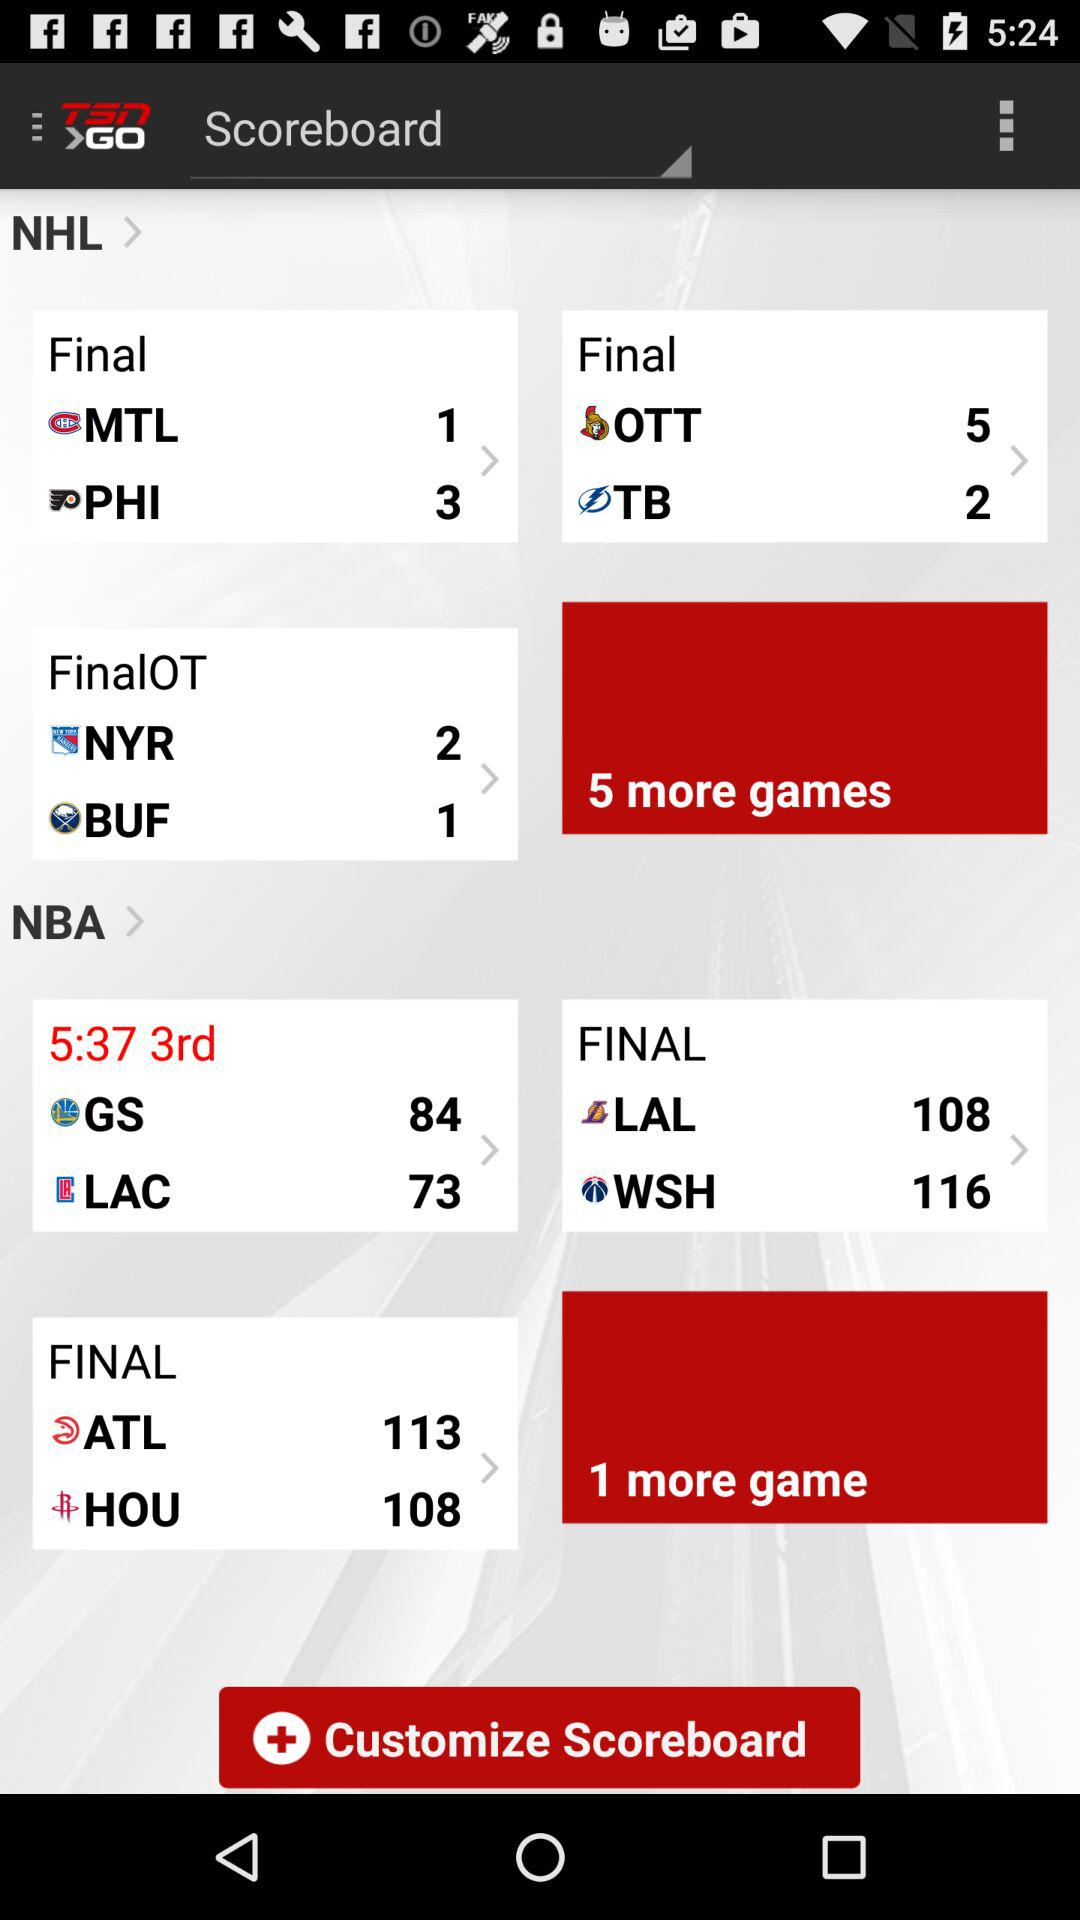What is the time left in the 3rd quarter of the match between GS and LAC? The time left in the 3rd quarter of the match between GS and LAC is 5 minutes 37 seconds. 